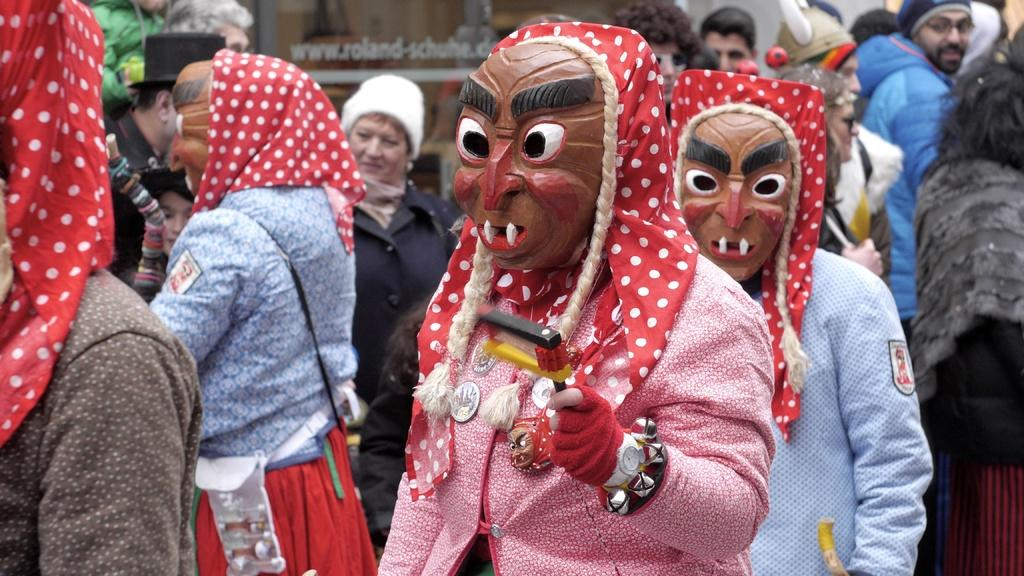How many people are in the image? There are persons in the image. What are the persons wearing on their faces? The persons are wearing masks. What are the persons holding in their hands? The persons are holding something. Can you see a girl playing with a yoke in the image? There is no girl or yoke present in the image. Is there a church visible in the background of the image? The provided facts do not mention any church or background, so we cannot determine if a church is visible. 